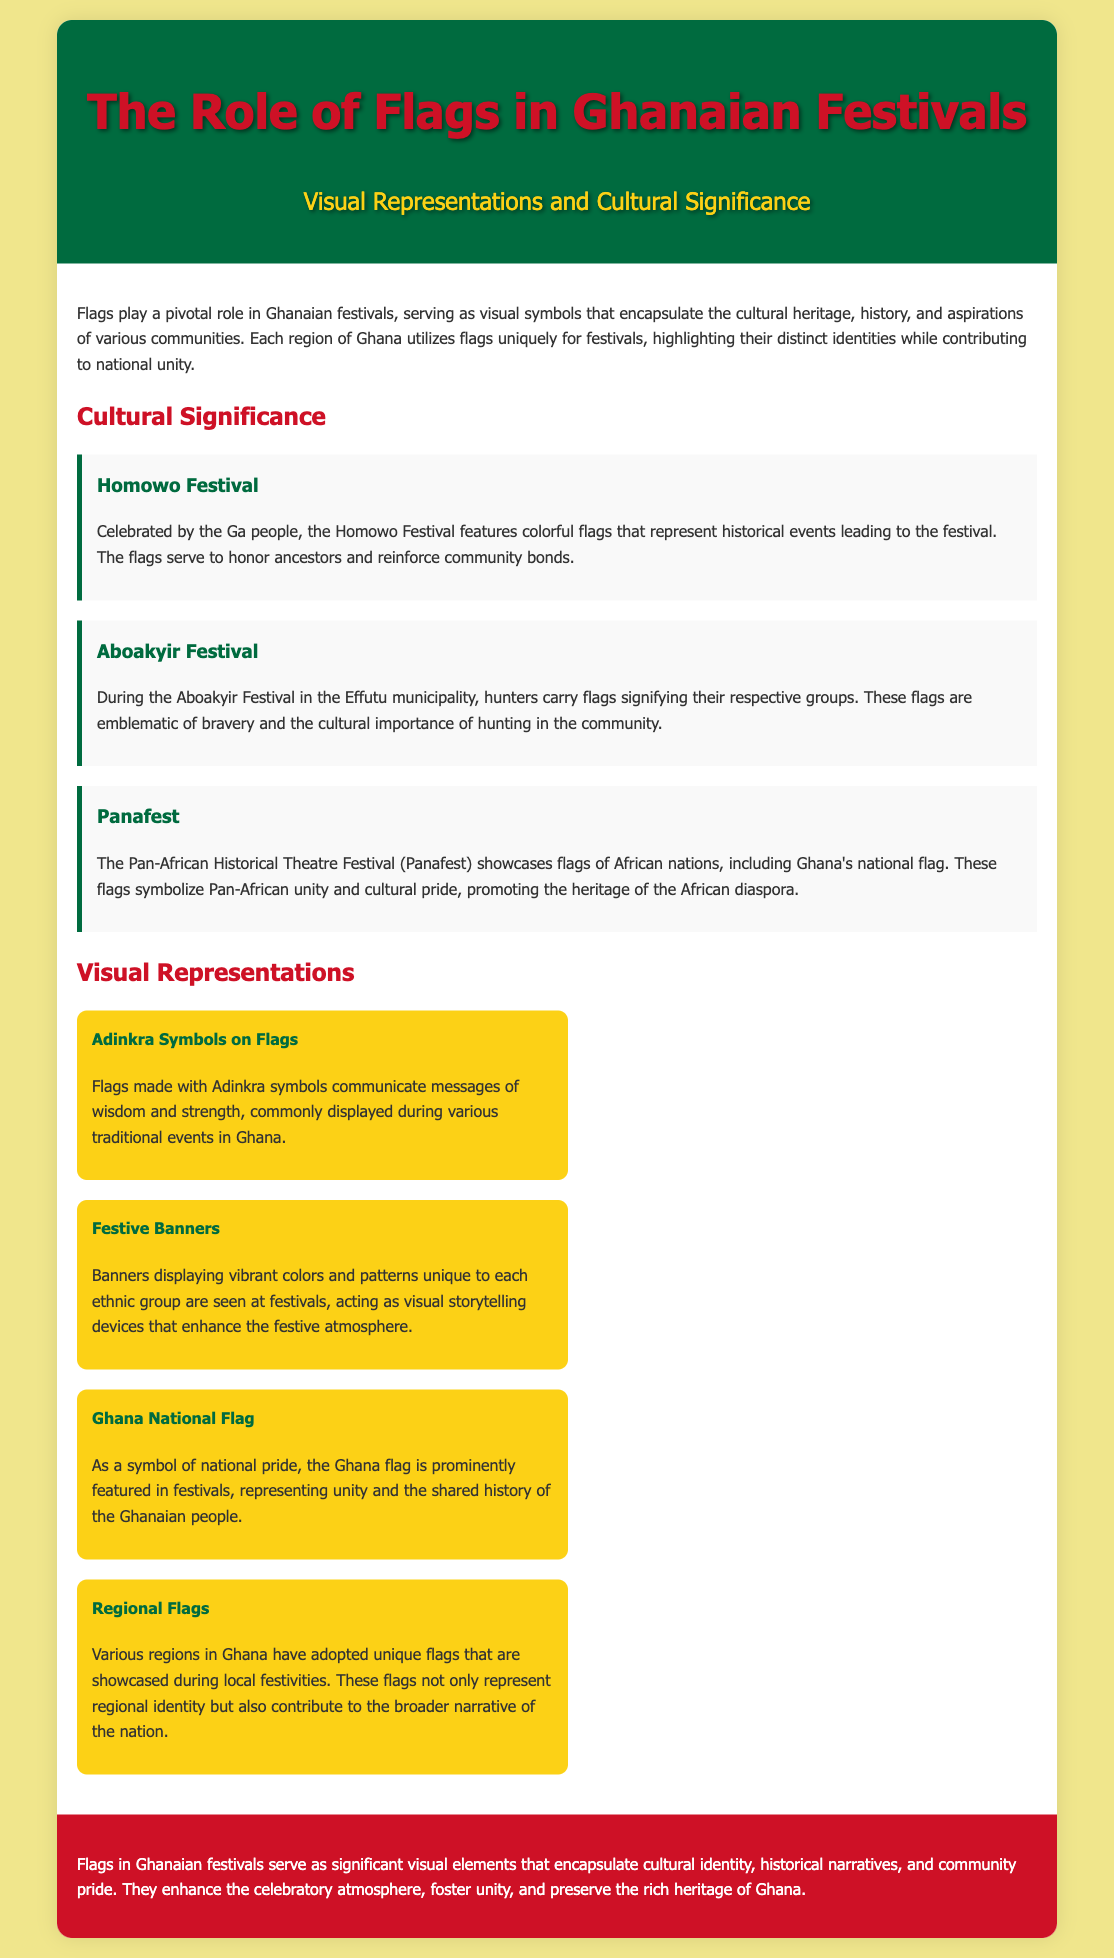What is the title of the document? The title is mentioned prominently at the top of the document, summarizing its theme.
Answer: The Role of Flags in Ghanaian Festivals Who celebrates the Homowo Festival? The document specifies the community that celebrates the Homowo Festival.
Answer: Ga people What is represented by flags during the Aboakyir Festival? The document states what the flags signify for the hunters during this festival.
Answer: Bravery What symbolism do flags used in Panafest represent? The document describes the broader meaning associated with the flags displayed at Panafest.
Answer: Pan-African unity What visual element is commonly used on flags during traditional events in Ghana? The document specifically mentions this visual element as part of flag design.
Answer: Adinkra symbols How many regions in Ghana display unique flags at festivals? The document refers to the number of regions with unique flags showcased at festivals.
Answer: Various regions What are festive banners described as in the document? The content defines the function of festive banners during festivals.
Answer: Visual storytelling devices What is the primary significance of the Ghana National Flag in festivals? The document highlights the broader meaning of displaying the national flag during events.
Answer: National pride 